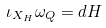Convert formula to latex. <formula><loc_0><loc_0><loc_500><loc_500>\iota _ { X _ { H } } \omega _ { Q } = d H</formula> 